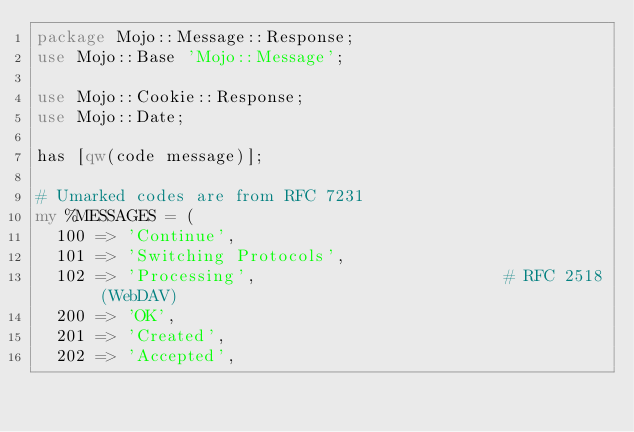Convert code to text. <code><loc_0><loc_0><loc_500><loc_500><_Perl_>package Mojo::Message::Response;
use Mojo::Base 'Mojo::Message';

use Mojo::Cookie::Response;
use Mojo::Date;

has [qw(code message)];

# Umarked codes are from RFC 7231
my %MESSAGES = (
  100 => 'Continue',
  101 => 'Switching Protocols',
  102 => 'Processing',                         # RFC 2518 (WebDAV)
  200 => 'OK',
  201 => 'Created',
  202 => 'Accepted',</code> 